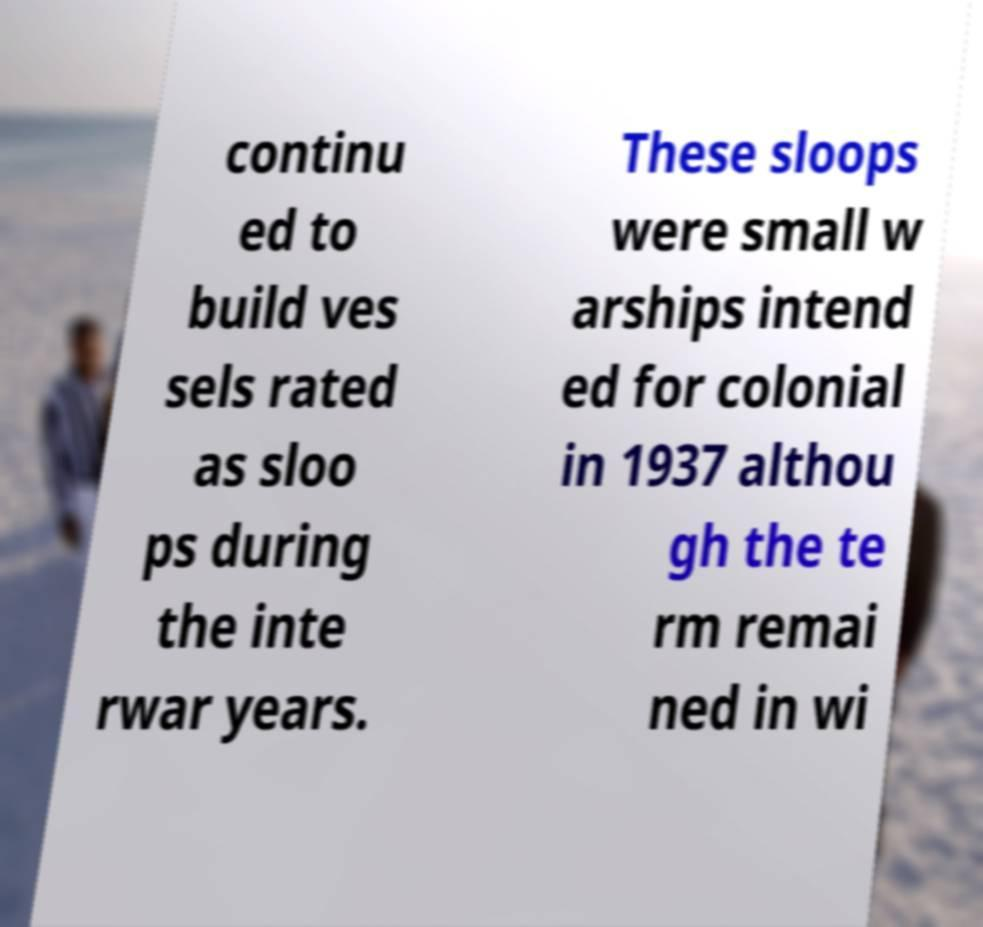Please identify and transcribe the text found in this image. continu ed to build ves sels rated as sloo ps during the inte rwar years. These sloops were small w arships intend ed for colonial in 1937 althou gh the te rm remai ned in wi 